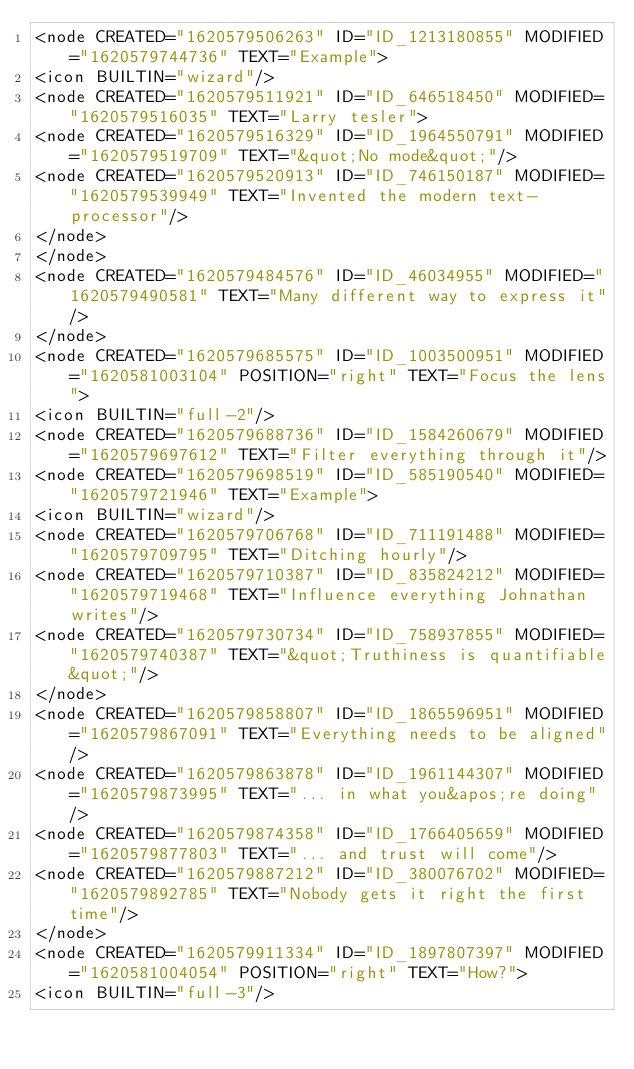Convert code to text. <code><loc_0><loc_0><loc_500><loc_500><_ObjectiveC_><node CREATED="1620579506263" ID="ID_1213180855" MODIFIED="1620579744736" TEXT="Example">
<icon BUILTIN="wizard"/>
<node CREATED="1620579511921" ID="ID_646518450" MODIFIED="1620579516035" TEXT="Larry tesler">
<node CREATED="1620579516329" ID="ID_1964550791" MODIFIED="1620579519709" TEXT="&quot;No mode&quot;"/>
<node CREATED="1620579520913" ID="ID_746150187" MODIFIED="1620579539949" TEXT="Invented the modern text-processor"/>
</node>
</node>
<node CREATED="1620579484576" ID="ID_46034955" MODIFIED="1620579490581" TEXT="Many different way to express it"/>
</node>
<node CREATED="1620579685575" ID="ID_1003500951" MODIFIED="1620581003104" POSITION="right" TEXT="Focus the lens">
<icon BUILTIN="full-2"/>
<node CREATED="1620579688736" ID="ID_1584260679" MODIFIED="1620579697612" TEXT="Filter everything through it"/>
<node CREATED="1620579698519" ID="ID_585190540" MODIFIED="1620579721946" TEXT="Example">
<icon BUILTIN="wizard"/>
<node CREATED="1620579706768" ID="ID_711191488" MODIFIED="1620579709795" TEXT="Ditching hourly"/>
<node CREATED="1620579710387" ID="ID_835824212" MODIFIED="1620579719468" TEXT="Influence everything Johnathan writes"/>
<node CREATED="1620579730734" ID="ID_758937855" MODIFIED="1620579740387" TEXT="&quot;Truthiness is quantifiable&quot;"/>
</node>
<node CREATED="1620579858807" ID="ID_1865596951" MODIFIED="1620579867091" TEXT="Everything needs to be aligned"/>
<node CREATED="1620579863878" ID="ID_1961144307" MODIFIED="1620579873995" TEXT="... in what you&apos;re doing"/>
<node CREATED="1620579874358" ID="ID_1766405659" MODIFIED="1620579877803" TEXT="... and trust will come"/>
<node CREATED="1620579887212" ID="ID_380076702" MODIFIED="1620579892785" TEXT="Nobody gets it right the first time"/>
</node>
<node CREATED="1620579911334" ID="ID_1897807397" MODIFIED="1620581004054" POSITION="right" TEXT="How?">
<icon BUILTIN="full-3"/></code> 